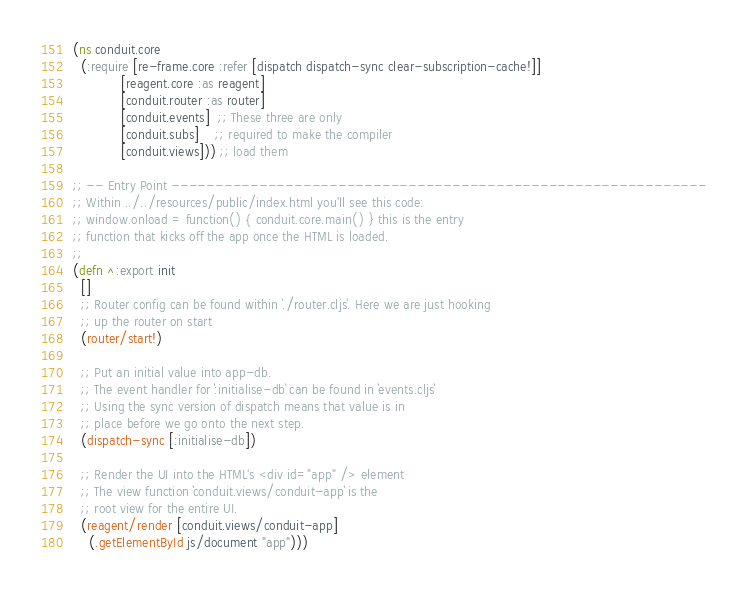Convert code to text. <code><loc_0><loc_0><loc_500><loc_500><_Clojure_>(ns conduit.core
  (:require [re-frame.core :refer [dispatch dispatch-sync clear-subscription-cache!]]
            [reagent.core :as reagent]
            [conduit.router :as router]
            [conduit.events]  ;; These three are only
            [conduit.subs]    ;; required to make the compiler
            [conduit.views])) ;; load them

;; -- Entry Point -------------------------------------------------------------
;; Within ../../resources/public/index.html you'll see this code:
;; window.onload = function() { conduit.core.main() } this is the entry 
;; function that kicks off the app once the HTML is loaded.
;;
(defn ^:export init
  []
  ;; Router config can be found within `./router.cljs`. Here we are just hooking
  ;; up the router on start
  (router/start!)

  ;; Put an initial value into app-db.
  ;; The event handler for `:initialise-db` can be found in `events.cljs`
  ;; Using the sync version of dispatch means that value is in
  ;; place before we go onto the next step.
  (dispatch-sync [:initialise-db])

  ;; Render the UI into the HTML's <div id="app" /> element
  ;; The view function `conduit.views/conduit-app` is the
  ;; root view for the entire UI.
  (reagent/render [conduit.views/conduit-app]
    (.getElementById js/document "app")))
</code> 